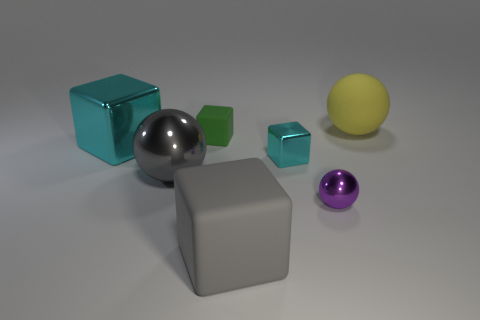Do the small cyan object and the small object that is behind the tiny cyan thing have the same shape?
Your answer should be very brief. Yes. There is a matte object that is left of the small sphere and behind the large gray cube; what size is it?
Offer a terse response. Small. The green rubber object is what shape?
Give a very brief answer. Cube. Are there any blocks behind the small cube that is to the right of the small rubber thing?
Give a very brief answer. Yes. There is a big ball in front of the big yellow ball; how many small metallic things are in front of it?
Provide a short and direct response. 1. There is a green block that is the same size as the purple sphere; what material is it?
Your answer should be compact. Rubber. Do the cyan metal thing that is to the right of the tiny green rubber object and the green object have the same shape?
Keep it short and to the point. Yes. Is the number of large cyan objects on the left side of the small cyan shiny object greater than the number of purple things that are in front of the purple object?
Make the answer very short. Yes. What number of big balls are made of the same material as the large gray cube?
Give a very brief answer. 1. Is the size of the green block the same as the purple metallic object?
Your answer should be compact. Yes. 